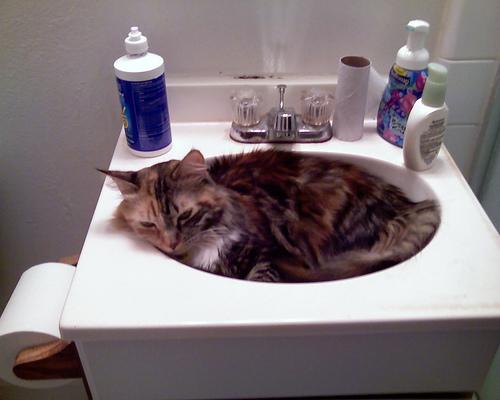What is the green liquid to the right?
Concise answer only. Soap. Is there any water in the sink?
Keep it brief. No. Is the toilet paper roll on the sink empty?
Short answer required. Yes. Is the cat sleeping?
Be succinct. No. Does this cat fit in the sink?
Short answer required. Yes. What is the animal in?
Give a very brief answer. Sink. 